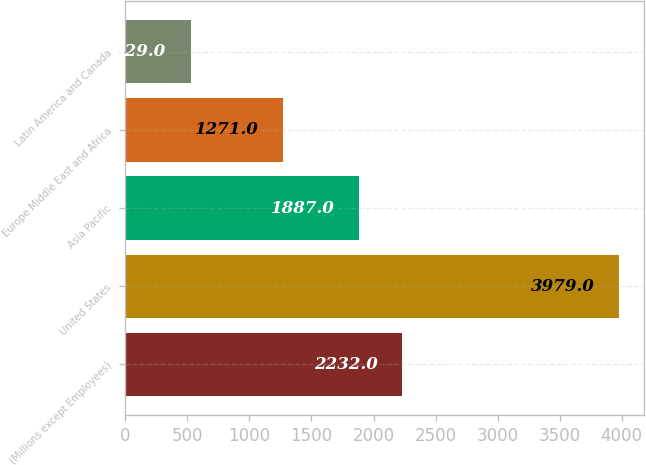Convert chart to OTSL. <chart><loc_0><loc_0><loc_500><loc_500><bar_chart><fcel>(Millions except Employees)<fcel>United States<fcel>Asia Pacific<fcel>Europe Middle East and Africa<fcel>Latin America and Canada<nl><fcel>2232<fcel>3979<fcel>1887<fcel>1271<fcel>529<nl></chart> 